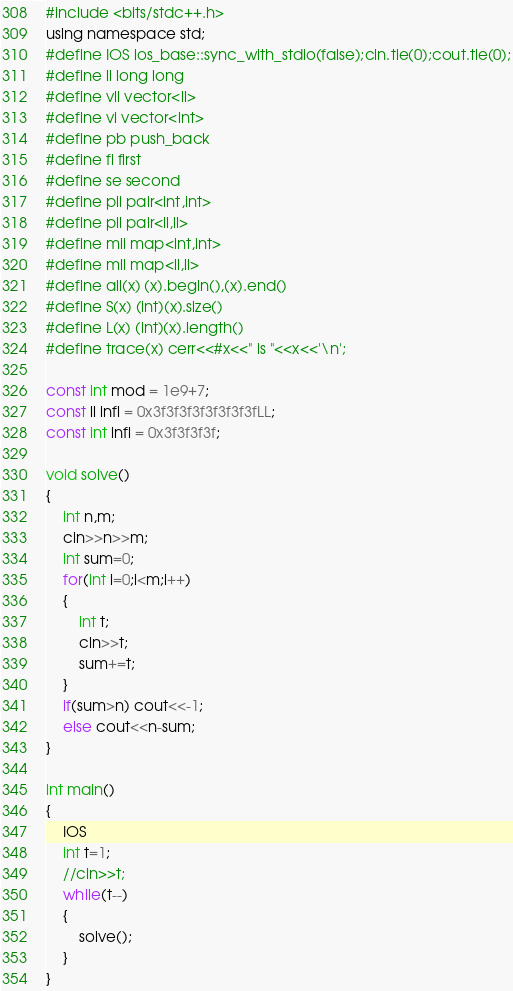<code> <loc_0><loc_0><loc_500><loc_500><_C_>#include <bits/stdc++.h>
using namespace std;
#define IOS ios_base::sync_with_stdio(false);cin.tie(0);cout.tie(0);
#define ll long long
#define vll vector<ll>
#define vi vector<int>
#define pb push_back
#define fi first
#define se second
#define pii pair<int,int>
#define pll pair<ll,ll>
#define mii map<int,int>
#define mll map<ll,ll>
#define all(x) (x).begin(),(x).end()
#define S(x) (int)(x).size()
#define L(x) (int)(x).length()
#define trace(x) cerr<<#x<<" is "<<x<<'\n';

const int mod = 1e9+7;
const ll infl = 0x3f3f3f3f3f3f3f3fLL;
const int infi = 0x3f3f3f3f;

void solve()
{
	int n,m;
	cin>>n>>m;
	int sum=0;
	for(int i=0;i<m;i++)
	{
		int t;
		cin>>t;
		sum+=t;
	}
	if(sum>n) cout<<-1;
	else cout<<n-sum;
}

int main()
{
	IOS
	int t=1;
	//cin>>t;
	while(t--)
	{
		solve();
	}
}
</code> 